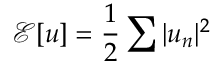<formula> <loc_0><loc_0><loc_500><loc_500>\mathcal { E } [ u ] = \frac { 1 } { 2 } \sum | u _ { n } | ^ { 2 }</formula> 